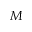Convert formula to latex. <formula><loc_0><loc_0><loc_500><loc_500>M</formula> 